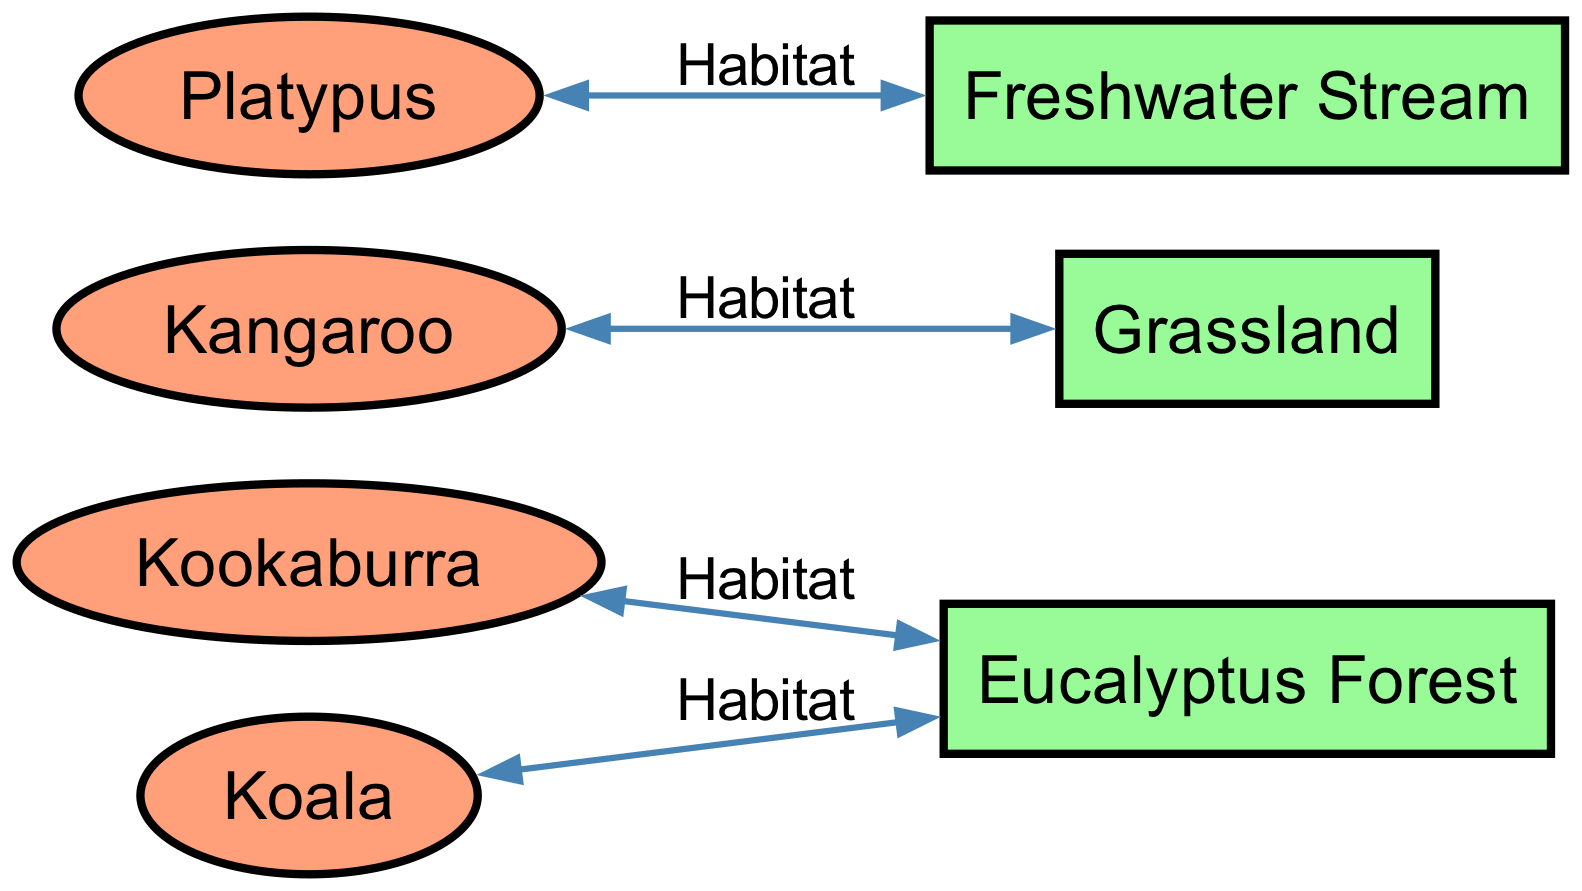What animal is connected to the Eucalyptus Forest? The diagram shows two animals linked to the Eucalyptus Forest: Kookaburra and Koala. By looking at the edges from the Eucalyptus Forest, I can see both animals are directly connected to it.
Answer: Kookaburra, Koala How many animals are shown in the diagram? The diagram indicates four different animals: Kookaburra, Koala, Kangaroo, and Platypus. Counting each distinct animal node confirms there are four animals present.
Answer: 4 What habitat is associated with the Kangaroo? The edge connecting the Kangaroo node shows that its habitat is Grassland. Therefore, by identifying the connection, I can determine the specific habitat where Kangaroo resides.
Answer: Grassland Which animal lives in a Freshwater Stream? By examining the edges from the Freshwater Stream, the Platypus is directly connected to it, indicating that this is the specific animal that inhabits this environment.
Answer: Platypus What type of node represents Eucalyptus Forest? The Eucalyptus Forest is represented by a rectangle node, which in this diagram denotes a habitat. This can be established by recognizing its shape and the distinction between animal and habitat nodes.
Answer: Rectangle 